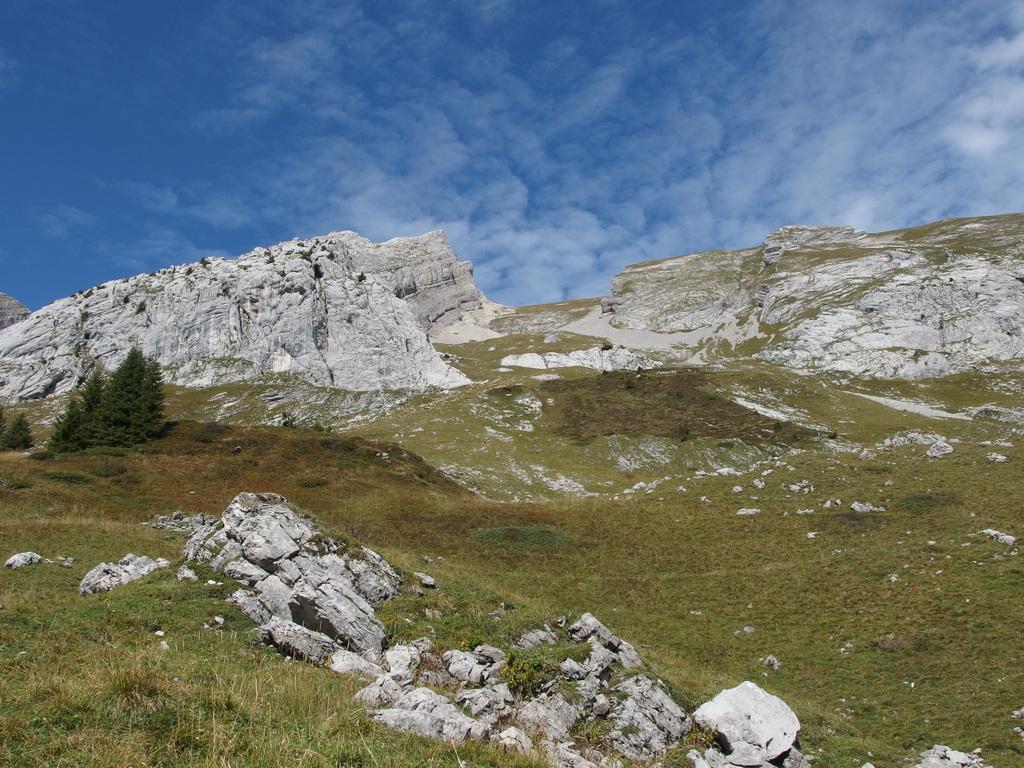Please provide a concise description of this image. Here in this picture we can see rocks present over there and we can see the ground is covered with grass and plants and trees present over there and we can also see clouds in the sky. 